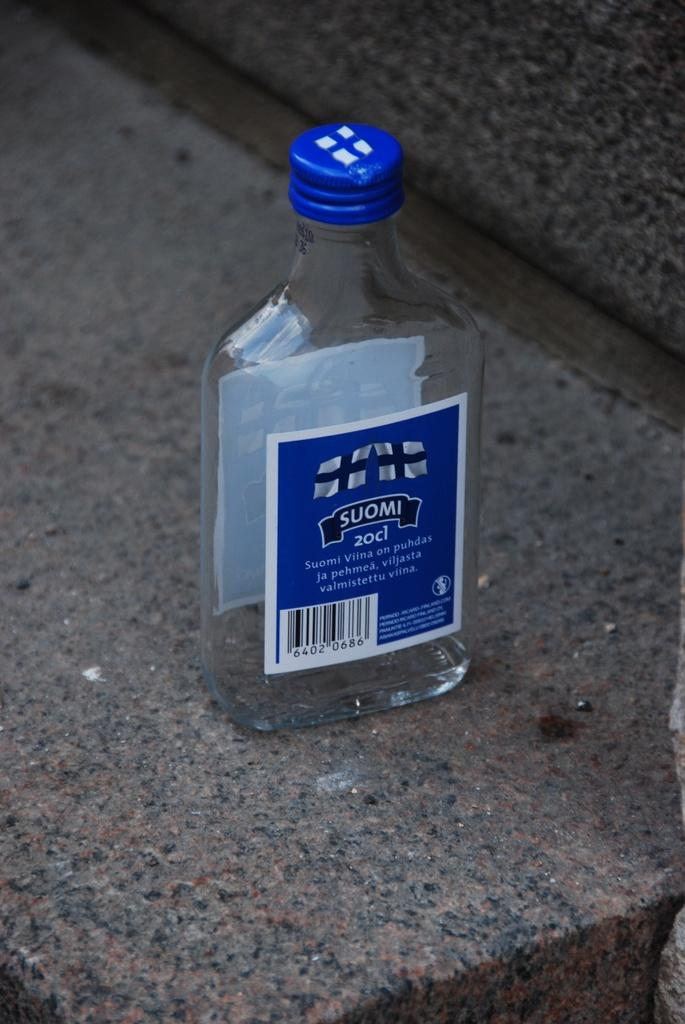<image>
Summarize the visual content of the image. A bottle of Suomi Viina 20cl sitting on a stone surface 